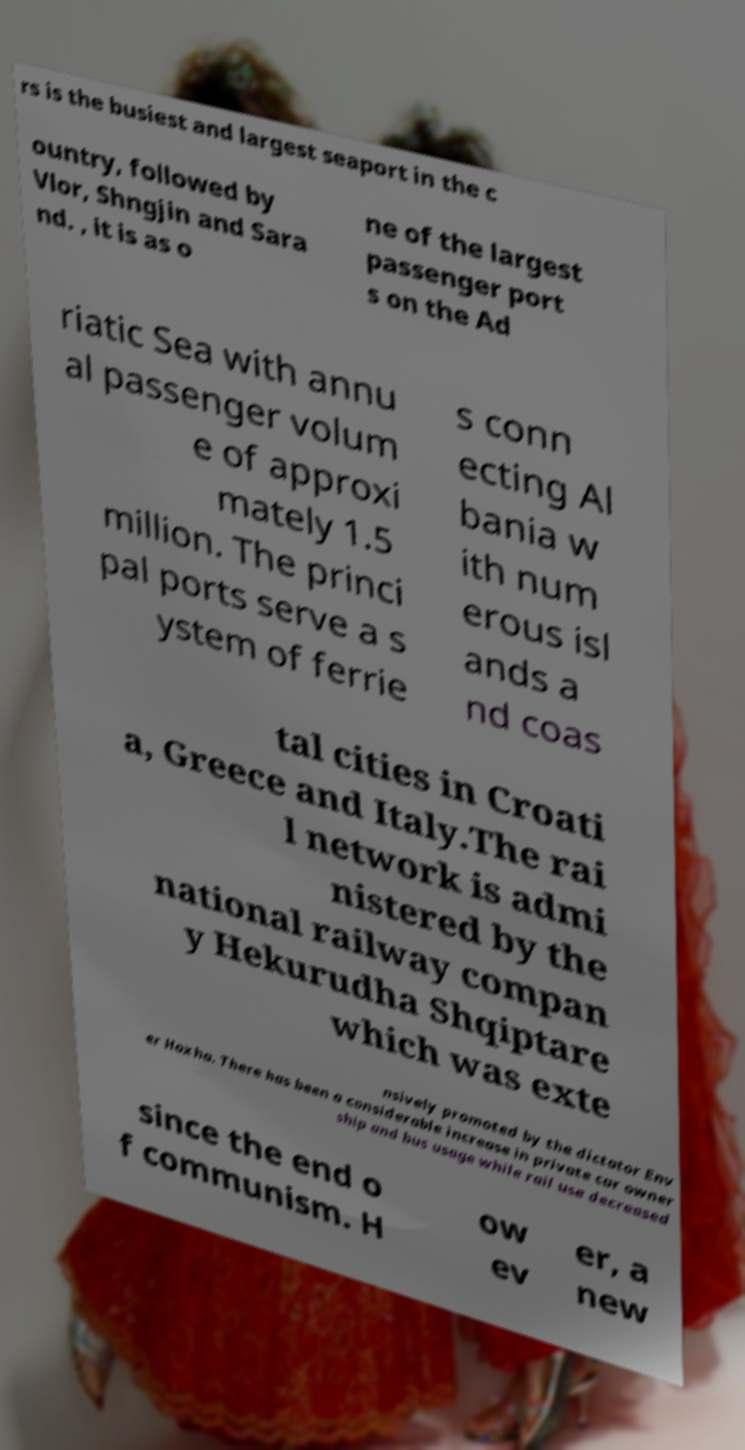Could you extract and type out the text from this image? rs is the busiest and largest seaport in the c ountry, followed by Vlor, Shngjin and Sara nd. , it is as o ne of the largest passenger port s on the Ad riatic Sea with annu al passenger volum e of approxi mately 1.5 million. The princi pal ports serve a s ystem of ferrie s conn ecting Al bania w ith num erous isl ands a nd coas tal cities in Croati a, Greece and Italy.The rai l network is admi nistered by the national railway compan y Hekurudha Shqiptare which was exte nsively promoted by the dictator Env er Hoxha. There has been a considerable increase in private car owner ship and bus usage while rail use decreased since the end o f communism. H ow ev er, a new 